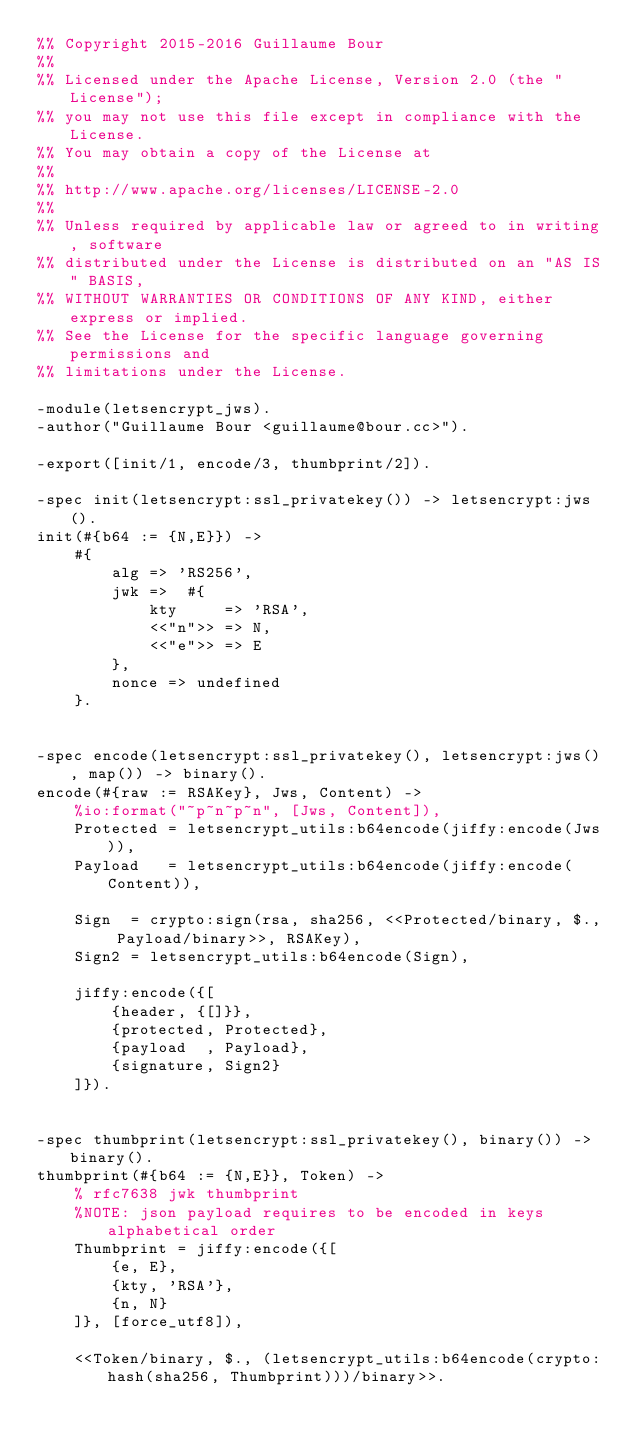<code> <loc_0><loc_0><loc_500><loc_500><_Erlang_>%% Copyright 2015-2016 Guillaume Bour
%% 
%% Licensed under the Apache License, Version 2.0 (the "License");
%% you may not use this file except in compliance with the License.
%% You may obtain a copy of the License at
%% 
%% http://www.apache.org/licenses/LICENSE-2.0
%% 
%% Unless required by applicable law or agreed to in writing, software
%% distributed under the License is distributed on an "AS IS" BASIS,
%% WITHOUT WARRANTIES OR CONDITIONS OF ANY KIND, either express or implied.
%% See the License for the specific language governing permissions and
%% limitations under the License.

-module(letsencrypt_jws).
-author("Guillaume Bour <guillaume@bour.cc>").

-export([init/1, encode/3, thumbprint/2]).

-spec init(letsencrypt:ssl_privatekey()) -> letsencrypt:jws().
init(#{b64 := {N,E}}) ->
    #{
        alg => 'RS256',
        jwk =>  #{
            kty     => 'RSA',
            <<"n">> => N,
            <<"e">> => E
        },
        nonce => undefined
    }.


-spec encode(letsencrypt:ssl_privatekey(), letsencrypt:jws(), map()) -> binary().
encode(#{raw := RSAKey}, Jws, Content) ->
    %io:format("~p~n~p~n", [Jws, Content]),
    Protected = letsencrypt_utils:b64encode(jiffy:encode(Jws)),
    Payload   = letsencrypt_utils:b64encode(jiffy:encode(Content)),

    Sign  = crypto:sign(rsa, sha256, <<Protected/binary, $., Payload/binary>>, RSAKey),
    Sign2 = letsencrypt_utils:b64encode(Sign),

    jiffy:encode({[
        {header, {[]}},
        {protected, Protected},
        {payload  , Payload},
        {signature, Sign2}
    ]}).


-spec thumbprint(letsencrypt:ssl_privatekey(), binary()) -> binary().
thumbprint(#{b64 := {N,E}}, Token) ->
    % rfc7638 jwk thumbprint
    %NOTE: json payload requires to be encoded in keys alphabetical order
    Thumbprint = jiffy:encode({[
        {e, E},
        {kty, 'RSA'},
        {n, N}
    ]}, [force_utf8]),

    <<Token/binary, $., (letsencrypt_utils:b64encode(crypto:hash(sha256, Thumbprint)))/binary>>.

</code> 